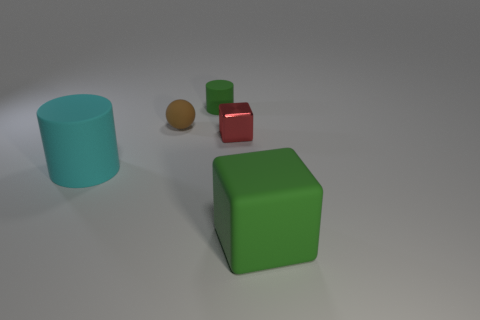Add 5 tiny purple metal cubes. How many objects exist? 10 Subtract all cubes. How many objects are left? 3 Add 1 large matte cubes. How many large matte cubes exist? 2 Subtract 0 yellow cubes. How many objects are left? 5 Subtract all small cyan rubber objects. Subtract all green blocks. How many objects are left? 4 Add 1 matte balls. How many matte balls are left? 2 